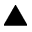<formula> <loc_0><loc_0><loc_500><loc_500>\blacktriangle</formula> 